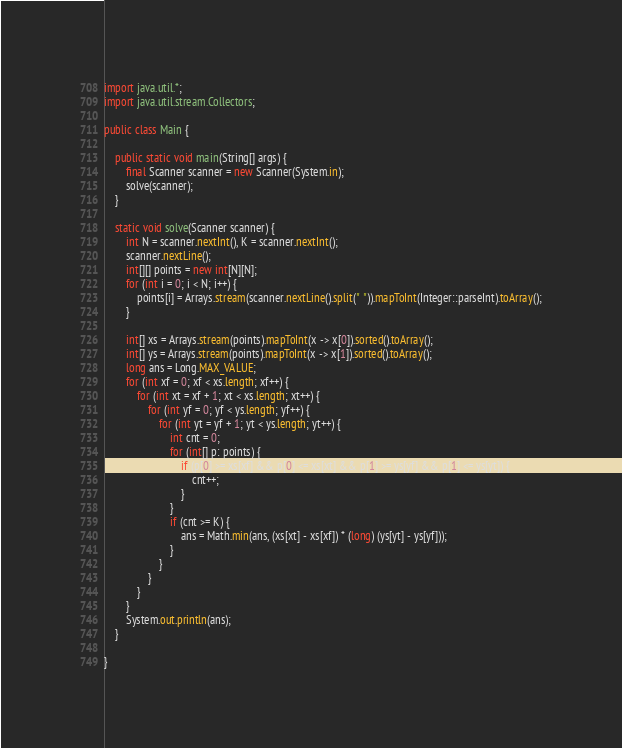<code> <loc_0><loc_0><loc_500><loc_500><_Java_>import java.util.*;
import java.util.stream.Collectors;

public class Main {

    public static void main(String[] args) {
        final Scanner scanner = new Scanner(System.in);
        solve(scanner);
    }

    static void solve(Scanner scanner) {
        int N = scanner.nextInt(), K = scanner.nextInt();
        scanner.nextLine();
        int[][] points = new int[N][N];
        for (int i = 0; i < N; i++) {
            points[i] = Arrays.stream(scanner.nextLine().split(" ")).mapToInt(Integer::parseInt).toArray();
        }

        int[] xs = Arrays.stream(points).mapToInt(x -> x[0]).sorted().toArray();
        int[] ys = Arrays.stream(points).mapToInt(x -> x[1]).sorted().toArray();
        long ans = Long.MAX_VALUE;
        for (int xf = 0; xf < xs.length; xf++) {
            for (int xt = xf + 1; xt < xs.length; xt++) {
                for (int yf = 0; yf < ys.length; yf++) {
                    for (int yt = yf + 1; yt < ys.length; yt++) {
                        int cnt = 0;
                        for (int[] p: points) {
                            if (p[0] >= xs[xf] && p[0] <= xs[xt] && p[1] >= ys[yf] && p[1] <= ys[yt]) {
                                cnt++;
                            }
                        }
                        if (cnt >= K) {
                            ans = Math.min(ans, (xs[xt] - xs[xf]) * (long) (ys[yt] - ys[yf]));
                        }
                    }
                }
            }
        }
        System.out.println(ans);
    }

}</code> 